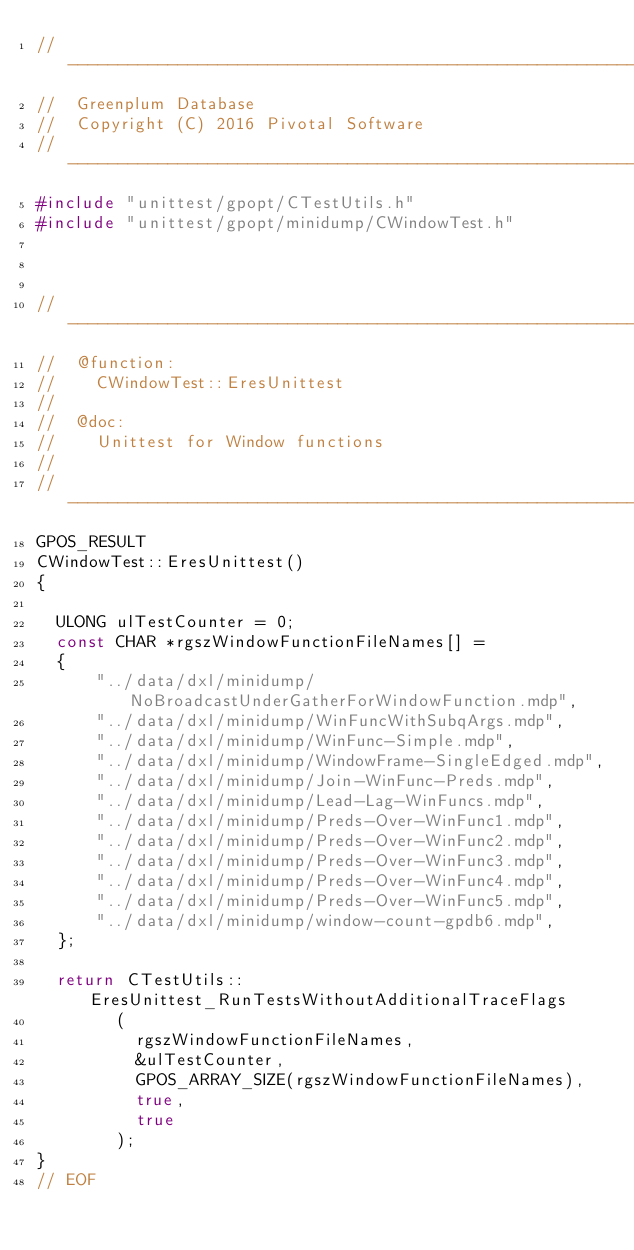Convert code to text. <code><loc_0><loc_0><loc_500><loc_500><_C++_>//---------------------------------------------------------------------------
//	Greenplum Database
//	Copyright (C) 2016 Pivotal Software
//---------------------------------------------------------------------------
#include "unittest/gpopt/CTestUtils.h"
#include "unittest/gpopt/minidump/CWindowTest.h"



//---------------------------------------------------------------------------
//	@function:
//		CWindowTest::EresUnittest
//
//	@doc:
//		Unittest for Window functions
//
//---------------------------------------------------------------------------
GPOS_RESULT
CWindowTest::EresUnittest()
{

	ULONG ulTestCounter = 0;
	const CHAR *rgszWindowFunctionFileNames[] =
	{
			"../data/dxl/minidump/NoBroadcastUnderGatherForWindowFunction.mdp",
			"../data/dxl/minidump/WinFuncWithSubqArgs.mdp",
			"../data/dxl/minidump/WinFunc-Simple.mdp",
			"../data/dxl/minidump/WindowFrame-SingleEdged.mdp",
			"../data/dxl/minidump/Join-WinFunc-Preds.mdp",
			"../data/dxl/minidump/Lead-Lag-WinFuncs.mdp",
			"../data/dxl/minidump/Preds-Over-WinFunc1.mdp",
			"../data/dxl/minidump/Preds-Over-WinFunc2.mdp",
			"../data/dxl/minidump/Preds-Over-WinFunc3.mdp",
			"../data/dxl/minidump/Preds-Over-WinFunc4.mdp",
			"../data/dxl/minidump/Preds-Over-WinFunc5.mdp",
			"../data/dxl/minidump/window-count-gpdb6.mdp",
	};

	return CTestUtils::EresUnittest_RunTestsWithoutAdditionalTraceFlags
				(
					rgszWindowFunctionFileNames,
					&ulTestCounter,
					GPOS_ARRAY_SIZE(rgszWindowFunctionFileNames),
					true,
					true
				);
}
// EOF
</code> 